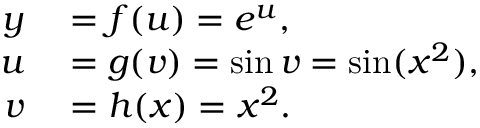Convert formula to latex. <formula><loc_0><loc_0><loc_500><loc_500>\begin{array} { r l } { y } & = f ( u ) = e ^ { u } , } \\ { u } & = g ( v ) = \sin v = \sin ( x ^ { 2 } ) , } \\ { v } & = h ( x ) = x ^ { 2 } . } \end{array}</formula> 